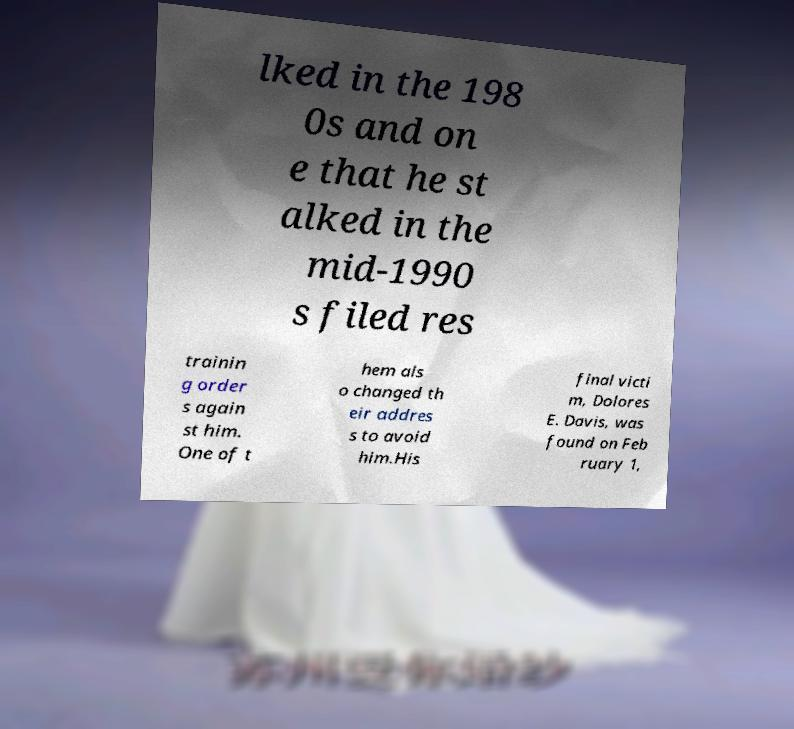What messages or text are displayed in this image? I need them in a readable, typed format. lked in the 198 0s and on e that he st alked in the mid-1990 s filed res trainin g order s again st him. One of t hem als o changed th eir addres s to avoid him.His final victi m, Dolores E. Davis, was found on Feb ruary 1, 